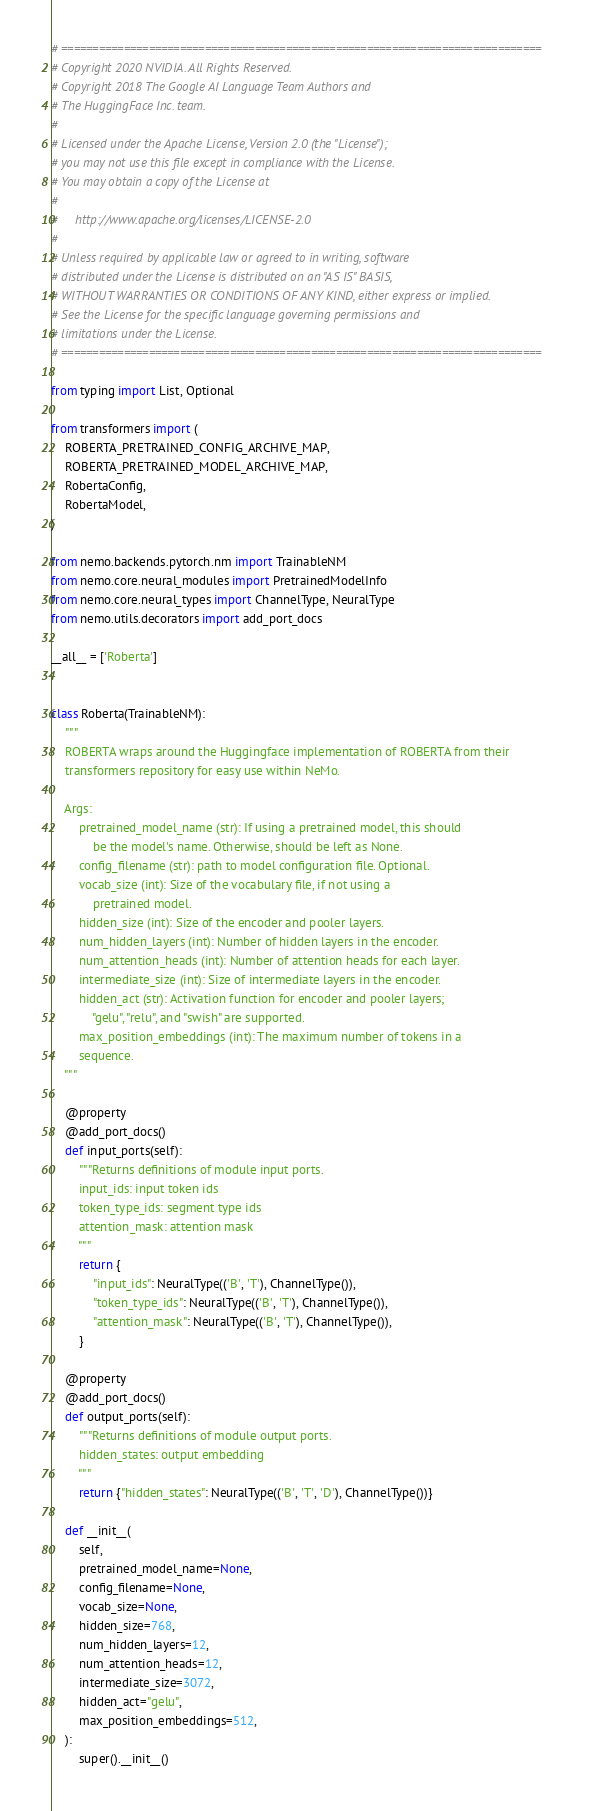Convert code to text. <code><loc_0><loc_0><loc_500><loc_500><_Python_># =============================================================================
# Copyright 2020 NVIDIA. All Rights Reserved.
# Copyright 2018 The Google AI Language Team Authors and
# The HuggingFace Inc. team.
#
# Licensed under the Apache License, Version 2.0 (the "License");
# you may not use this file except in compliance with the License.
# You may obtain a copy of the License at
#
#     http://www.apache.org/licenses/LICENSE-2.0
#
# Unless required by applicable law or agreed to in writing, software
# distributed under the License is distributed on an "AS IS" BASIS,
# WITHOUT WARRANTIES OR CONDITIONS OF ANY KIND, either express or implied.
# See the License for the specific language governing permissions and
# limitations under the License.
# =============================================================================

from typing import List, Optional

from transformers import (
    ROBERTA_PRETRAINED_CONFIG_ARCHIVE_MAP,
    ROBERTA_PRETRAINED_MODEL_ARCHIVE_MAP,
    RobertaConfig,
    RobertaModel,
)

from nemo.backends.pytorch.nm import TrainableNM
from nemo.core.neural_modules import PretrainedModelInfo
from nemo.core.neural_types import ChannelType, NeuralType
from nemo.utils.decorators import add_port_docs

__all__ = ['Roberta']


class Roberta(TrainableNM):
    """
    ROBERTA wraps around the Huggingface implementation of ROBERTA from their
    transformers repository for easy use within NeMo.

    Args:
        pretrained_model_name (str): If using a pretrained model, this should
            be the model's name. Otherwise, should be left as None.
        config_filename (str): path to model configuration file. Optional.
        vocab_size (int): Size of the vocabulary file, if not using a
            pretrained model.
        hidden_size (int): Size of the encoder and pooler layers.
        num_hidden_layers (int): Number of hidden layers in the encoder.
        num_attention_heads (int): Number of attention heads for each layer.
        intermediate_size (int): Size of intermediate layers in the encoder.
        hidden_act (str): Activation function for encoder and pooler layers;
            "gelu", "relu", and "swish" are supported.
        max_position_embeddings (int): The maximum number of tokens in a
        sequence.
    """

    @property
    @add_port_docs()
    def input_ports(self):
        """Returns definitions of module input ports.
        input_ids: input token ids
        token_type_ids: segment type ids
        attention_mask: attention mask
        """
        return {
            "input_ids": NeuralType(('B', 'T'), ChannelType()),
            "token_type_ids": NeuralType(('B', 'T'), ChannelType()),
            "attention_mask": NeuralType(('B', 'T'), ChannelType()),
        }

    @property
    @add_port_docs()
    def output_ports(self):
        """Returns definitions of module output ports.
        hidden_states: output embedding 
        """
        return {"hidden_states": NeuralType(('B', 'T', 'D'), ChannelType())}

    def __init__(
        self,
        pretrained_model_name=None,
        config_filename=None,
        vocab_size=None,
        hidden_size=768,
        num_hidden_layers=12,
        num_attention_heads=12,
        intermediate_size=3072,
        hidden_act="gelu",
        max_position_embeddings=512,
    ):
        super().__init__()
</code> 